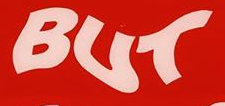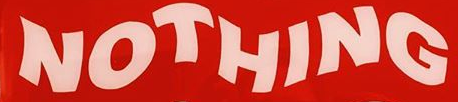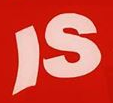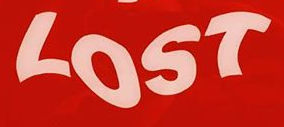Read the text content from these images in order, separated by a semicolon. BUT; NOTHING; IS; LOST 